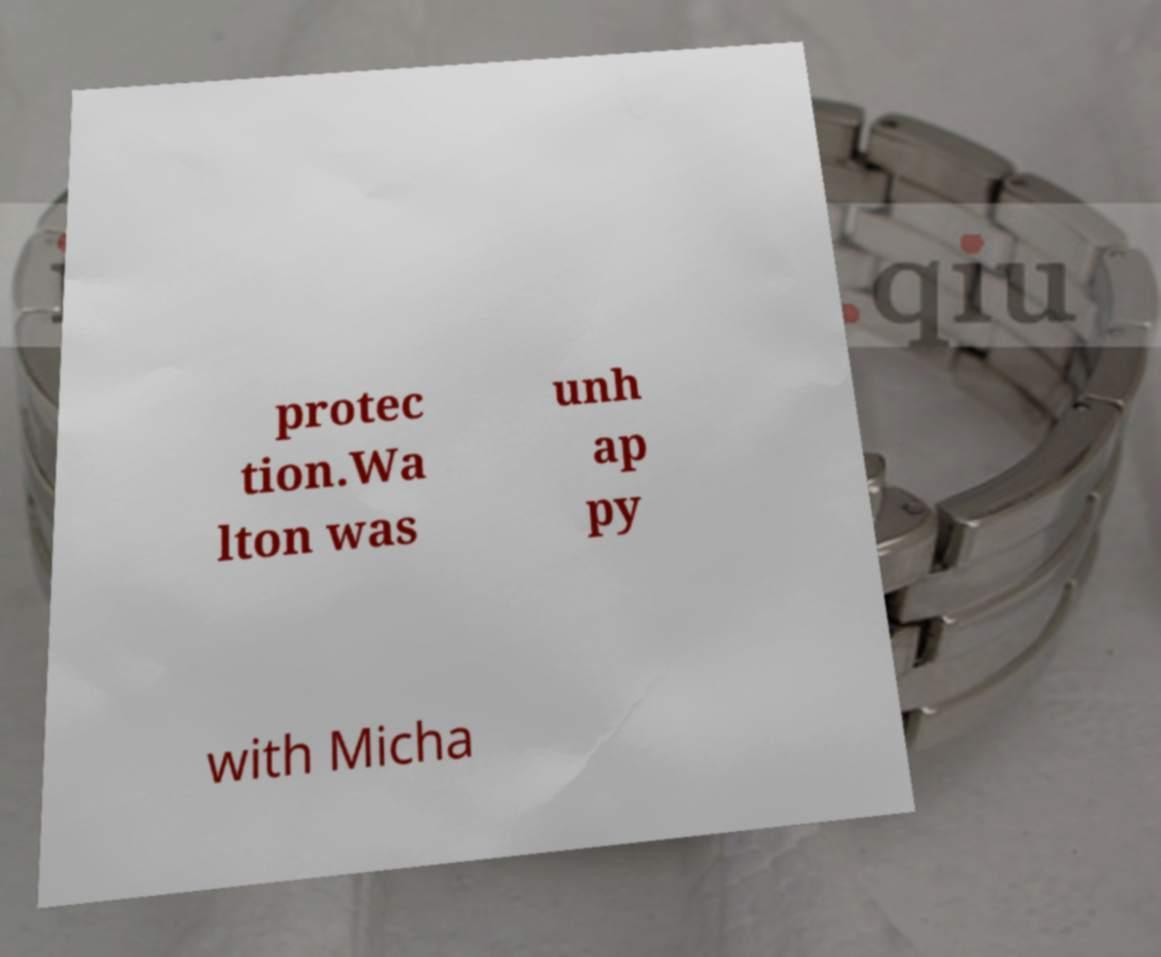Could you assist in decoding the text presented in this image and type it out clearly? protec tion.Wa lton was unh ap py with Micha 